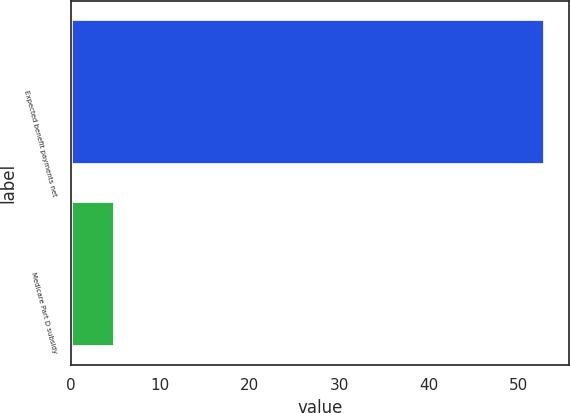Convert chart. <chart><loc_0><loc_0><loc_500><loc_500><bar_chart><fcel>Expected benefit payments net<fcel>Medicare Part D subsidy<nl><fcel>53<fcel>5<nl></chart> 